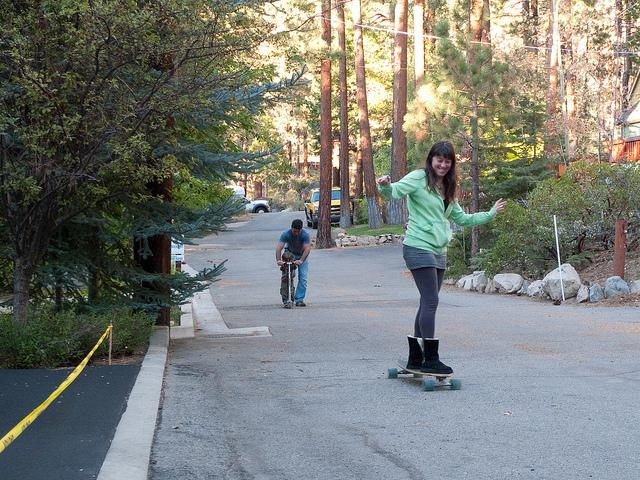What is the Man teaching the child?

Choices:
A) steeple chasing
B) freebasing
C) scooter riding
D) sky diving scooter riding 